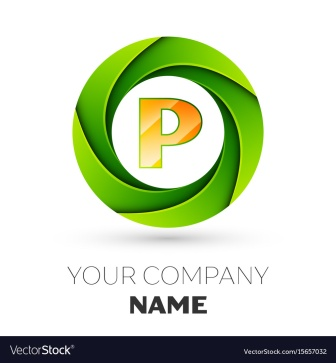What is this photo about'?
 The image presents a logo design for a company. Dominating the center of the image is a green circle, within which nestles an orange letter "P". The "P" is slightly tilted to the right, adding a dynamic touch to the design. Underneath this emblem, the phrase "YOUR COMPANY NAME" is written in black, serving as a placeholder for the actual name of the company. The entire design stands out against a stark white background, highlighting the vibrancy of the green and orange colors. 